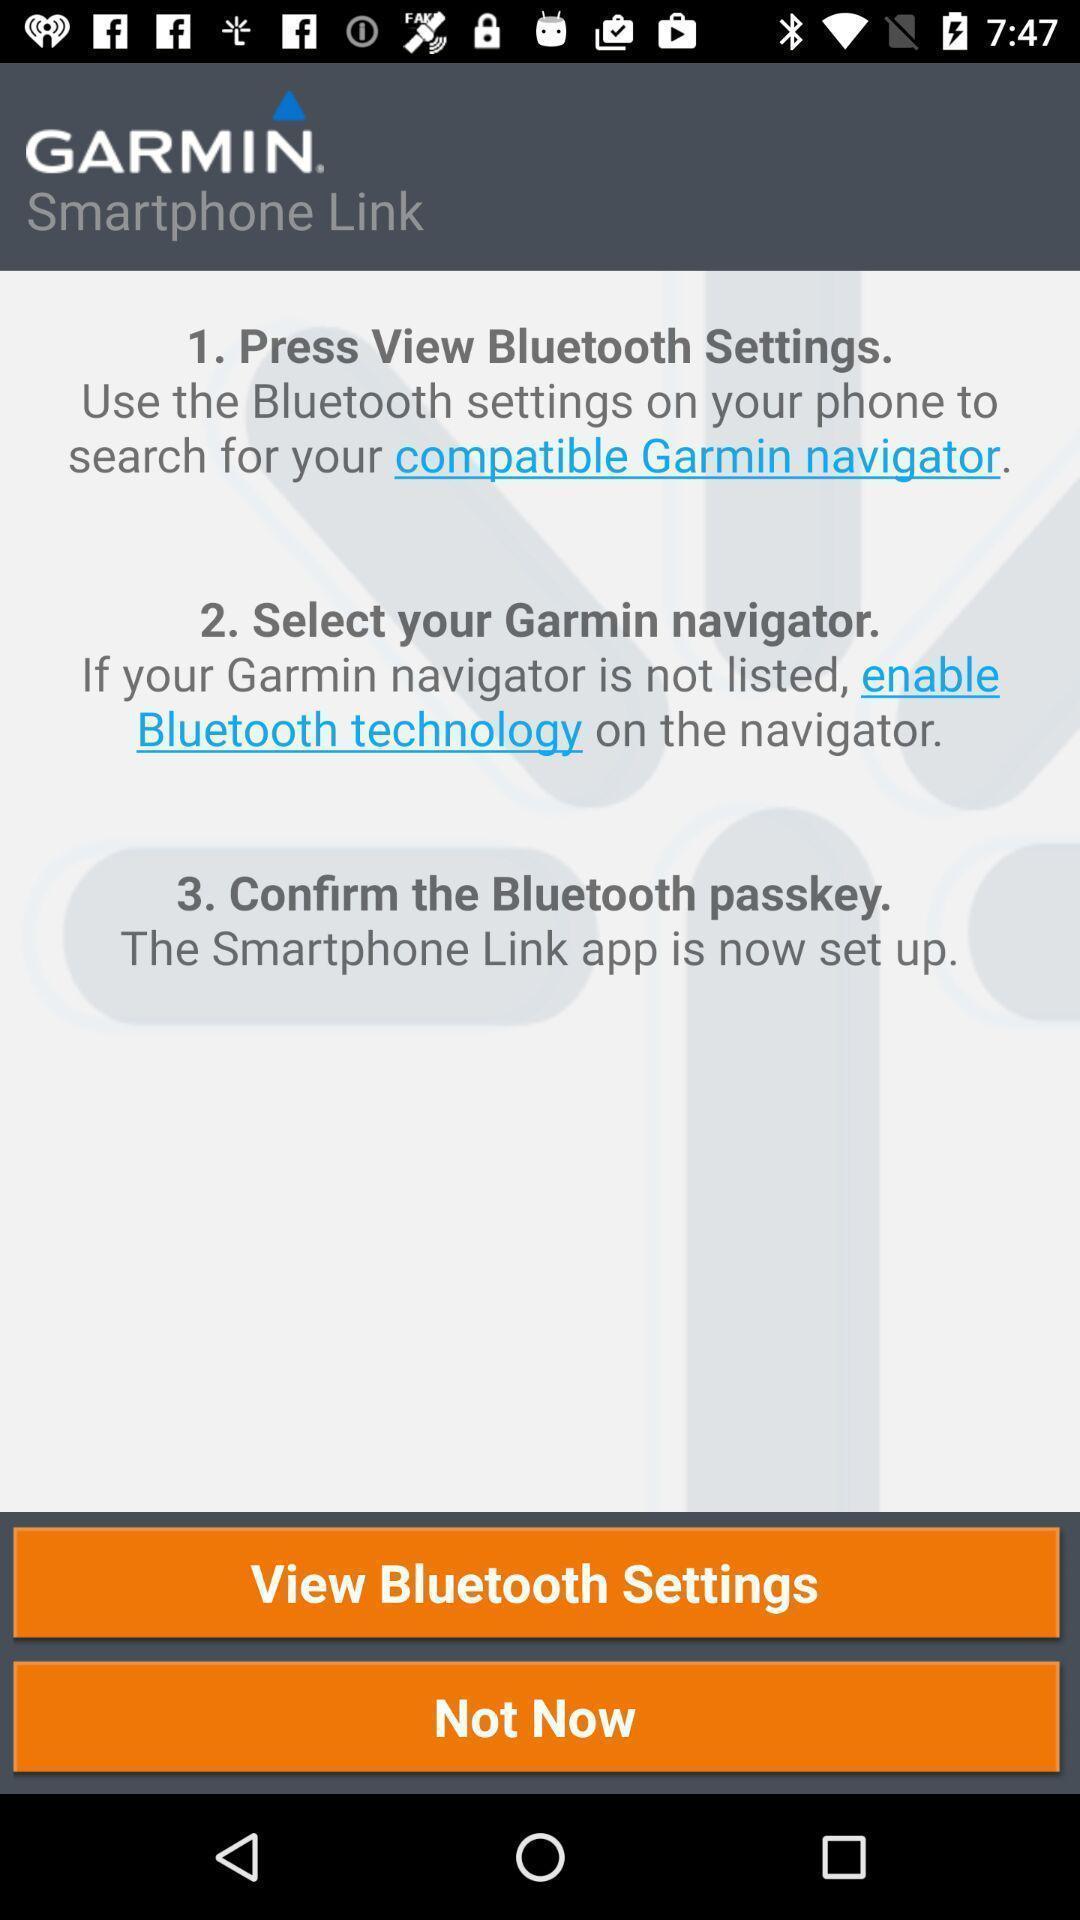Give me a summary of this screen capture. Screen displaying the instructions fro bluetooth settings. 